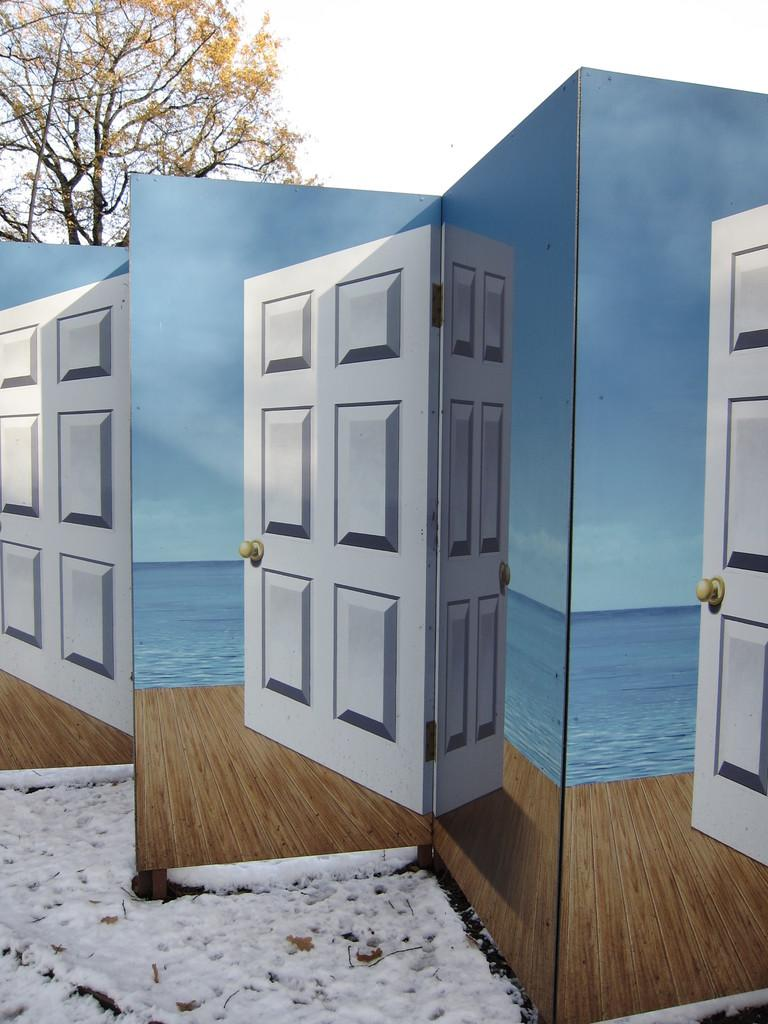What objects are present in the image that have doors? There are boards in the image that have doors. What type of flooring is visible in the image? There is a wooden floor in the image. What natural element can be seen in the image? There is water visible in the image. What can be seen in the background of the image? There is a tree and the sky visible in the background of the image. How many screws are visible on the airplane in the image? There is no airplane present in the image, so there are no screws to count. 